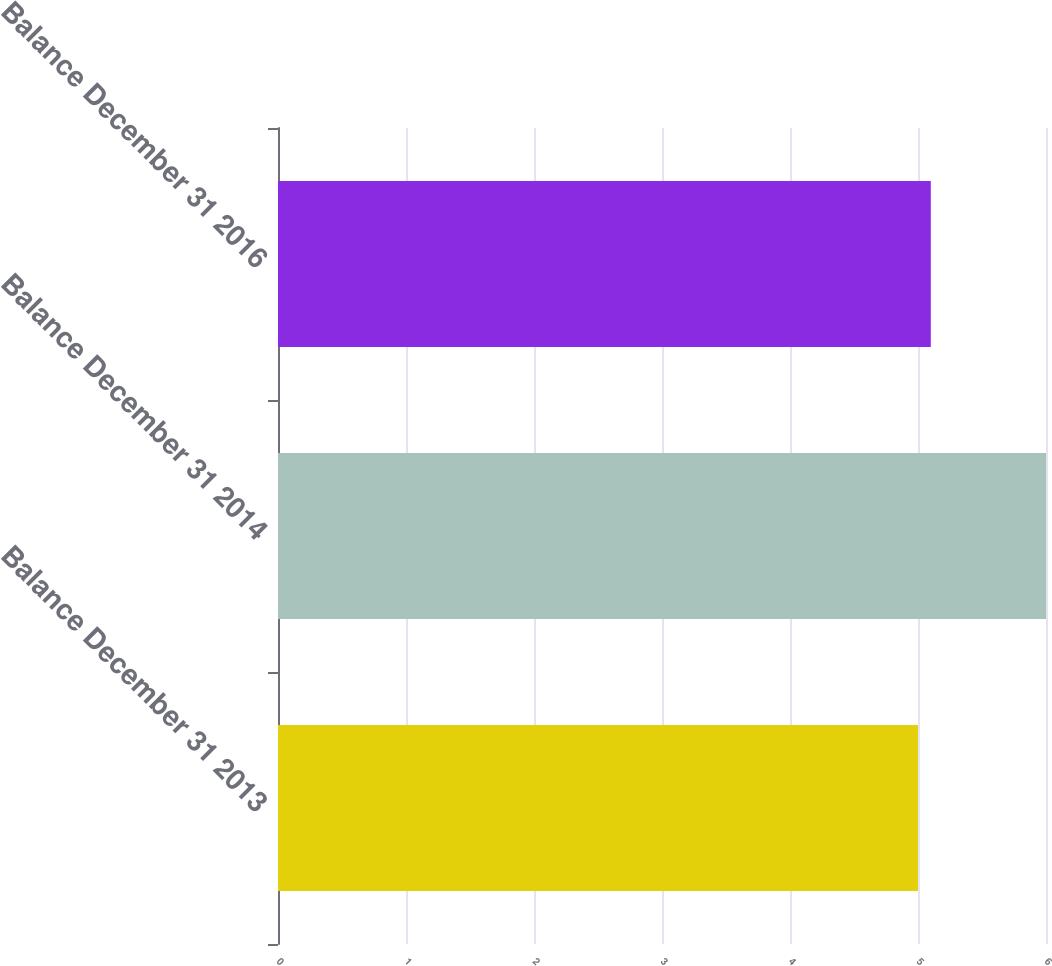Convert chart to OTSL. <chart><loc_0><loc_0><loc_500><loc_500><bar_chart><fcel>Balance December 31 2013<fcel>Balance December 31 2014<fcel>Balance December 31 2016<nl><fcel>5<fcel>6<fcel>5.1<nl></chart> 